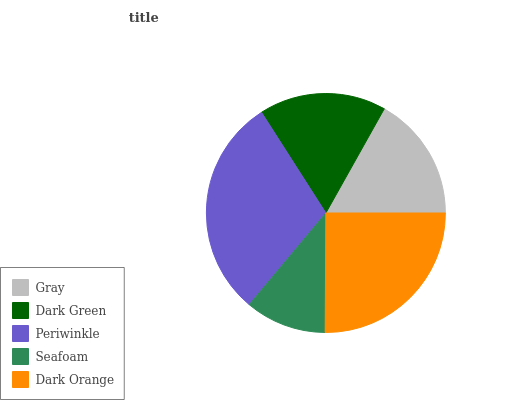Is Seafoam the minimum?
Answer yes or no. Yes. Is Periwinkle the maximum?
Answer yes or no. Yes. Is Dark Green the minimum?
Answer yes or no. No. Is Dark Green the maximum?
Answer yes or no. No. Is Dark Green greater than Gray?
Answer yes or no. Yes. Is Gray less than Dark Green?
Answer yes or no. Yes. Is Gray greater than Dark Green?
Answer yes or no. No. Is Dark Green less than Gray?
Answer yes or no. No. Is Dark Green the high median?
Answer yes or no. Yes. Is Dark Green the low median?
Answer yes or no. Yes. Is Dark Orange the high median?
Answer yes or no. No. Is Periwinkle the low median?
Answer yes or no. No. 